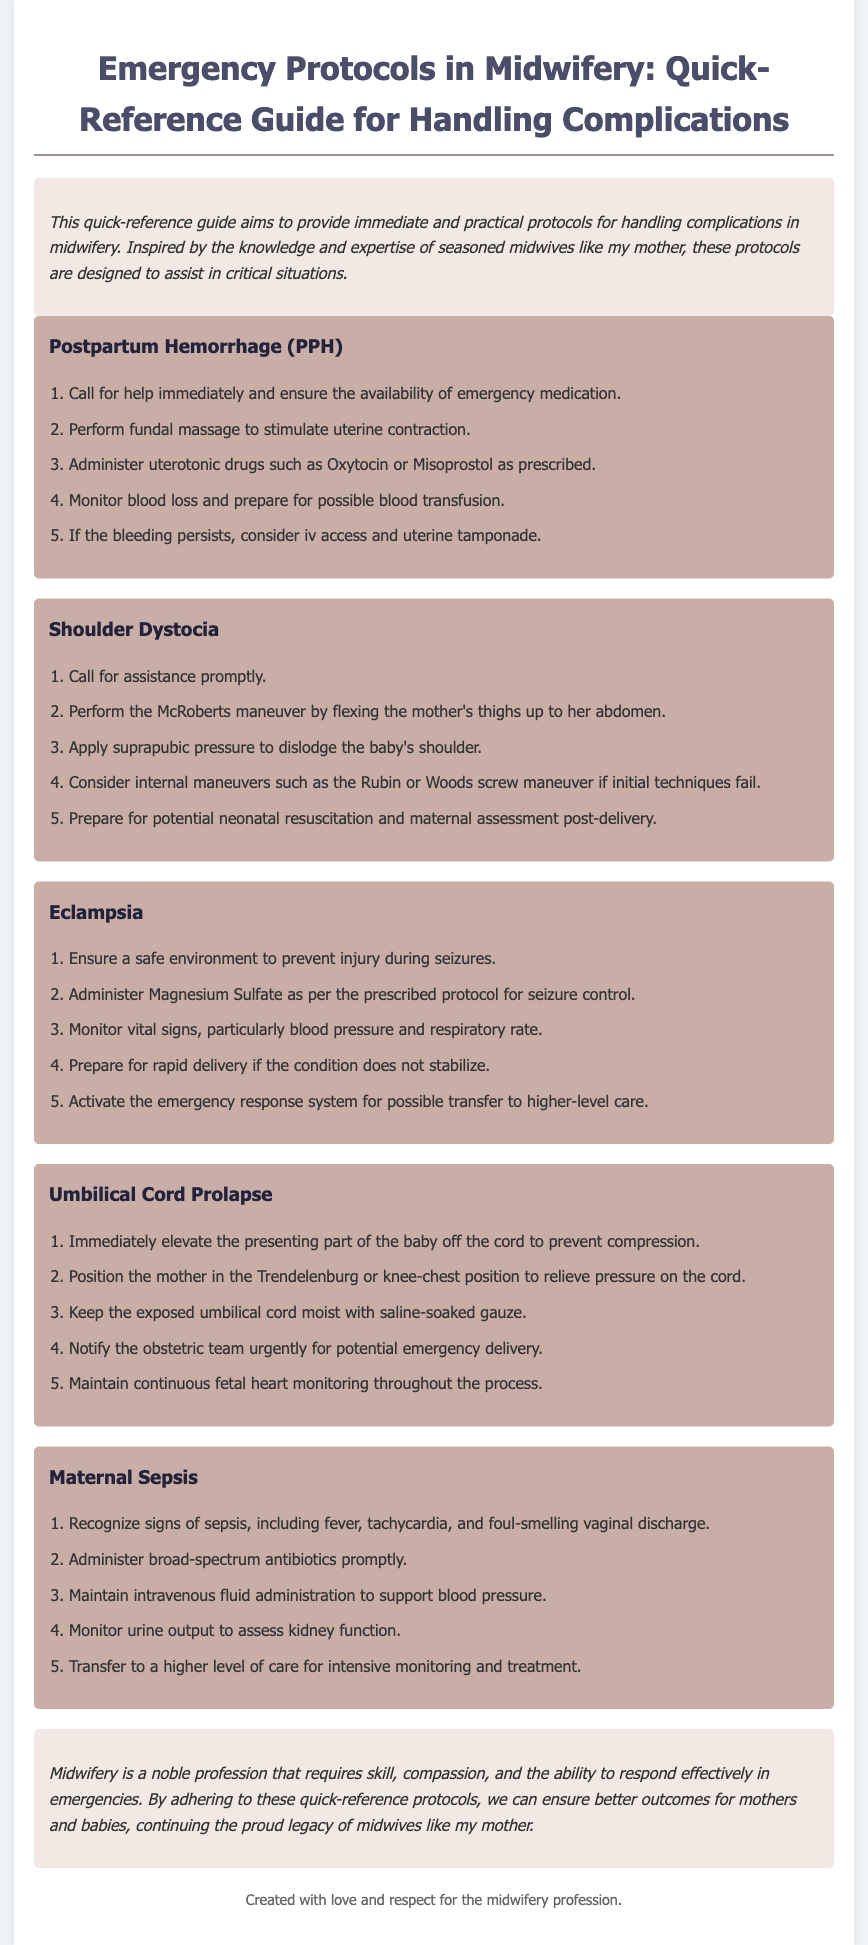What is the title of the document? The title of the document is provided at the top of the rendered page and summarizes its content regarding emergency protocols in midwifery.
Answer: Emergency Protocols in Midwifery: Quick-Reference Guide for Handling Complications How many main protocols are described in the guide? The document lists five specific protocols within the emergency guidelines, each addressing a unique complication.
Answer: 5 What is the first step for managing Postpartum Hemorrhage? The document outlines the first step in handling Postpartum Hemorrhage, emphasizing the importance of immediate assistance and medication.
Answer: Call for help immediately and ensure the availability of emergency medication What medication is administered for seizure control in Eclampsia? The guide specifies the medication that should be given for managing seizures during Eclampsia, highlighting its critical role in treatment.
Answer: Magnesium Sulfate What maneuver is recommended for Shoulder Dystocia? The document highlights a specific maneuver that is recommended to assist in resolving Shoulder Dystocia, reflecting standard practice in midwifery.
Answer: McRoberts maneuver What position should a mother be in for Umbilical Cord Prolapse? The recommended position for a mother experiencing Umbilical Cord Prolapse is described in the document as a means to alleviate pressure on the cord.
Answer: Trendelenburg or knee-chest position Which symptom might indicate Maternal Sepsis? The guide lists various signs associated with Maternal Sepsis, helping practitioners to recognize the condition promptly.
Answer: Fever How does this guide assist midwives in emergencies? The document explains its purpose in aiding midwives during critical situations with structured protocols for various complications, emphasizing practical support.
Answer: Provides immediate and practical protocols for handling complications 